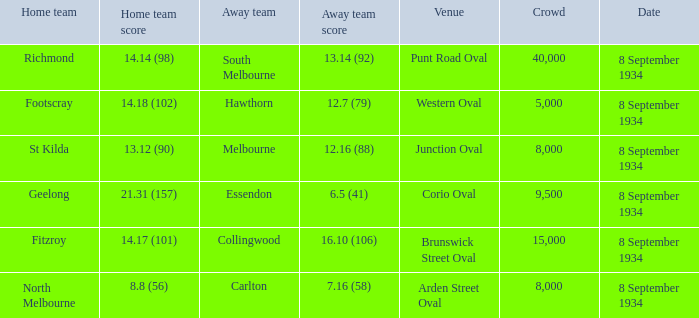Parse the full table. {'header': ['Home team', 'Home team score', 'Away team', 'Away team score', 'Venue', 'Crowd', 'Date'], 'rows': [['Richmond', '14.14 (98)', 'South Melbourne', '13.14 (92)', 'Punt Road Oval', '40,000', '8 September 1934'], ['Footscray', '14.18 (102)', 'Hawthorn', '12.7 (79)', 'Western Oval', '5,000', '8 September 1934'], ['St Kilda', '13.12 (90)', 'Melbourne', '12.16 (88)', 'Junction Oval', '8,000', '8 September 1934'], ['Geelong', '21.31 (157)', 'Essendon', '6.5 (41)', 'Corio Oval', '9,500', '8 September 1934'], ['Fitzroy', '14.17 (101)', 'Collingwood', '16.10 (106)', 'Brunswick Street Oval', '15,000', '8 September 1934'], ['North Melbourne', '8.8 (56)', 'Carlton', '7.16 (58)', 'Arden Street Oval', '8,000', '8 September 1934']]} 14 (98), what did the away team accomplish? 13.14 (92). 